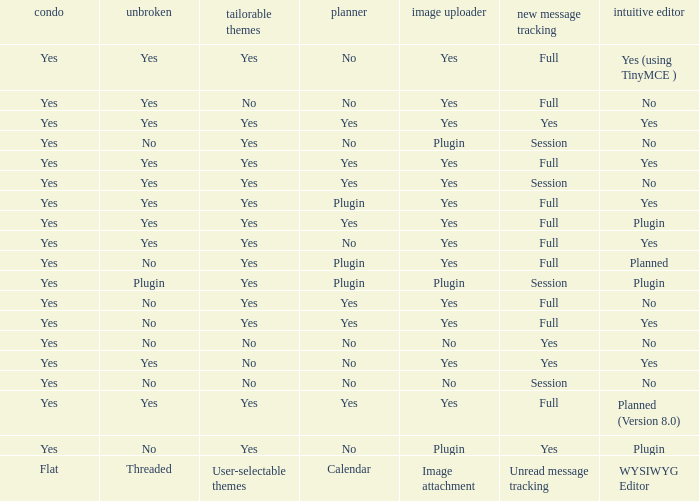Which Image attachment has a Threaded of yes, and a Calendar of yes? Yes, Yes, Yes, Yes, Yes. 